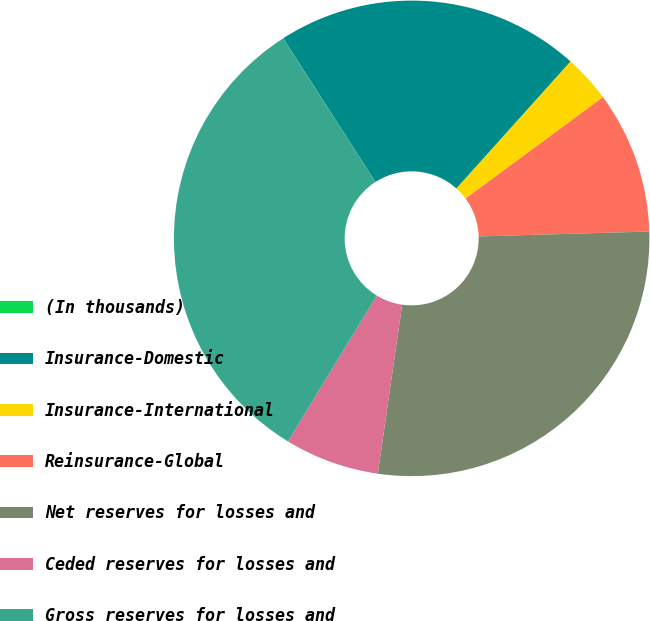<chart> <loc_0><loc_0><loc_500><loc_500><pie_chart><fcel>(In thousands)<fcel>Insurance-Domestic<fcel>Insurance-International<fcel>Reinsurance-Global<fcel>Net reserves for losses and<fcel>Ceded reserves for losses and<fcel>Gross reserves for losses and<nl><fcel>0.01%<fcel>20.74%<fcel>3.23%<fcel>9.66%<fcel>27.73%<fcel>6.44%<fcel>32.19%<nl></chart> 